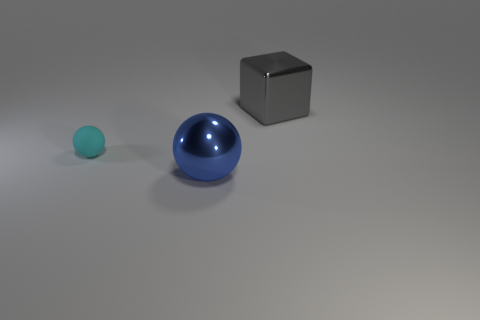Subtract all blue spheres. How many spheres are left? 1 Add 2 small brown shiny cylinders. How many objects exist? 5 Subtract 0 green cylinders. How many objects are left? 3 Subtract all spheres. How many objects are left? 1 Subtract 1 spheres. How many spheres are left? 1 Subtract all purple spheres. Subtract all cyan cylinders. How many spheres are left? 2 Subtract all green cylinders. How many cyan balls are left? 1 Subtract all blue metal objects. Subtract all green rubber balls. How many objects are left? 2 Add 3 large blue metallic balls. How many large blue metallic balls are left? 4 Add 2 cyan matte balls. How many cyan matte balls exist? 3 